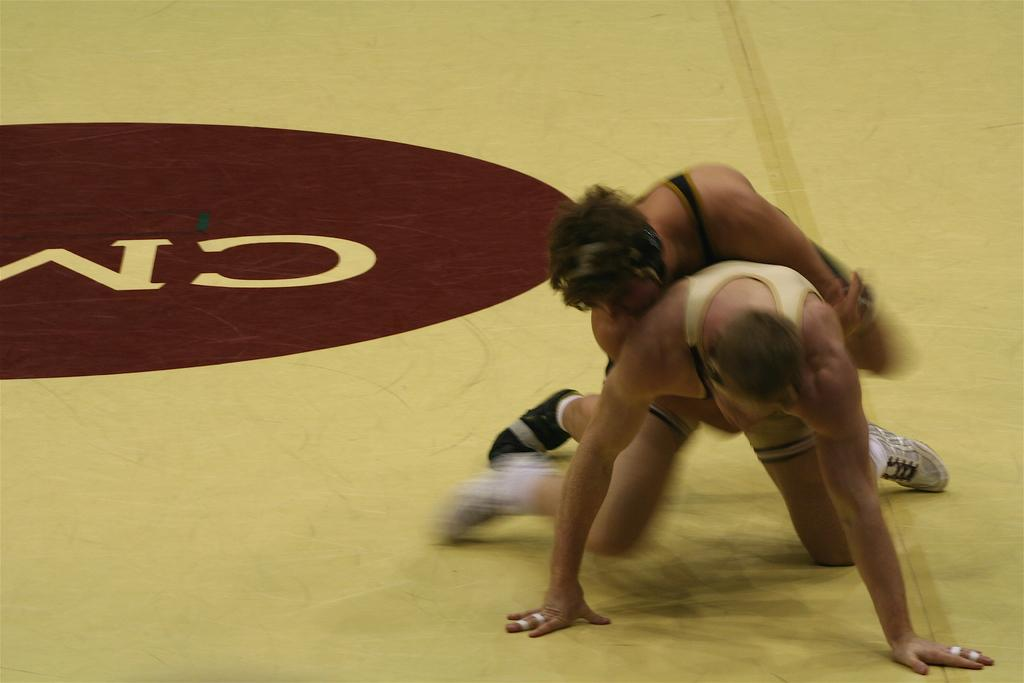How many people are in the image? There are two persons in the image. What is the position of the persons in the image? Both persons are on the ground. What is one person doing to the other person in the image? One person is holding the other person. What type of jeans is the pest wearing in the image? There is no pest present in the image, and therefore no one is wearing jeans. 